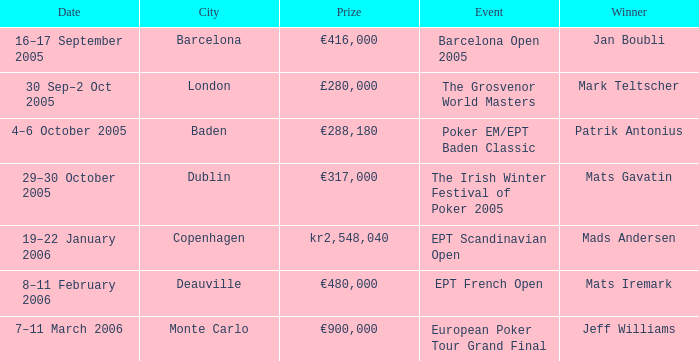What city did an event have a prize of €288,180? Baden. 